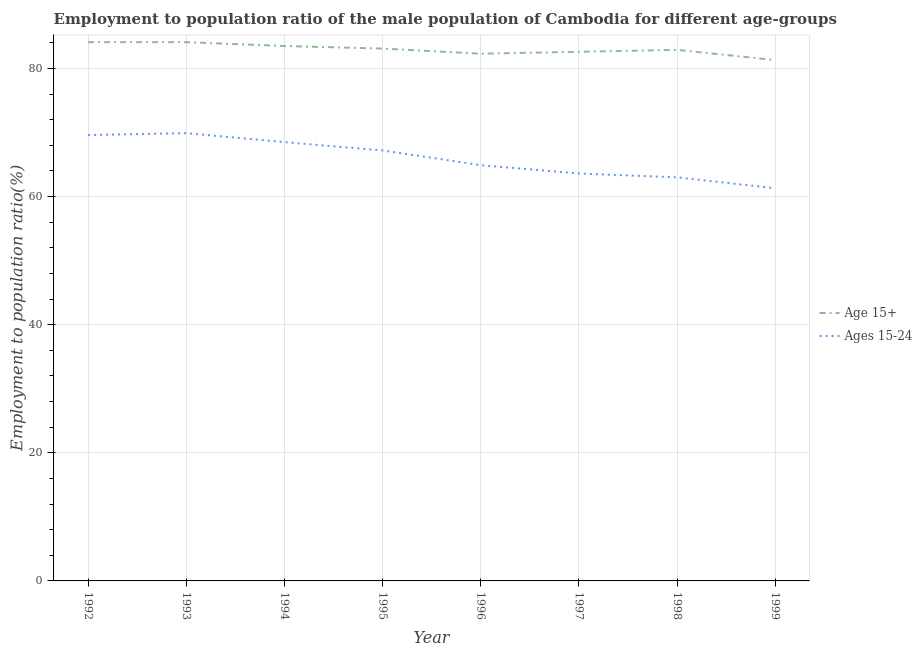Does the line corresponding to employment to population ratio(age 15-24) intersect with the line corresponding to employment to population ratio(age 15+)?
Make the answer very short. No. Is the number of lines equal to the number of legend labels?
Ensure brevity in your answer.  Yes. What is the employment to population ratio(age 15-24) in 1996?
Your response must be concise. 64.9. Across all years, what is the maximum employment to population ratio(age 15+)?
Your answer should be very brief. 84.1. Across all years, what is the minimum employment to population ratio(age 15-24)?
Make the answer very short. 61.3. In which year was the employment to population ratio(age 15+) maximum?
Your response must be concise. 1992. In which year was the employment to population ratio(age 15-24) minimum?
Provide a succinct answer. 1999. What is the total employment to population ratio(age 15-24) in the graph?
Provide a succinct answer. 528. What is the difference between the employment to population ratio(age 15+) in 1995 and that in 1997?
Offer a very short reply. 0.5. What is the difference between the employment to population ratio(age 15-24) in 1997 and the employment to population ratio(age 15+) in 1993?
Your response must be concise. -20.5. What is the average employment to population ratio(age 15+) per year?
Your answer should be very brief. 82.99. In the year 1993, what is the difference between the employment to population ratio(age 15+) and employment to population ratio(age 15-24)?
Your response must be concise. 14.2. In how many years, is the employment to population ratio(age 15+) greater than 24 %?
Provide a short and direct response. 8. What is the ratio of the employment to population ratio(age 15+) in 1998 to that in 1999?
Your response must be concise. 1.02. Is the employment to population ratio(age 15+) in 1995 less than that in 1998?
Provide a succinct answer. No. Is the difference between the employment to population ratio(age 15-24) in 1997 and 1999 greater than the difference between the employment to population ratio(age 15+) in 1997 and 1999?
Give a very brief answer. Yes. What is the difference between the highest and the second highest employment to population ratio(age 15+)?
Give a very brief answer. 0. What is the difference between the highest and the lowest employment to population ratio(age 15+)?
Ensure brevity in your answer.  2.8. In how many years, is the employment to population ratio(age 15-24) greater than the average employment to population ratio(age 15-24) taken over all years?
Make the answer very short. 4. Is the employment to population ratio(age 15-24) strictly greater than the employment to population ratio(age 15+) over the years?
Give a very brief answer. No. Is the employment to population ratio(age 15+) strictly less than the employment to population ratio(age 15-24) over the years?
Keep it short and to the point. No. How many lines are there?
Your answer should be compact. 2. Does the graph contain any zero values?
Provide a short and direct response. No. Does the graph contain grids?
Ensure brevity in your answer.  Yes. Where does the legend appear in the graph?
Your answer should be very brief. Center right. What is the title of the graph?
Provide a short and direct response. Employment to population ratio of the male population of Cambodia for different age-groups. Does "Import" appear as one of the legend labels in the graph?
Offer a very short reply. No. What is the Employment to population ratio(%) of Age 15+ in 1992?
Keep it short and to the point. 84.1. What is the Employment to population ratio(%) in Ages 15-24 in 1992?
Ensure brevity in your answer.  69.6. What is the Employment to population ratio(%) in Age 15+ in 1993?
Give a very brief answer. 84.1. What is the Employment to population ratio(%) in Ages 15-24 in 1993?
Offer a terse response. 69.9. What is the Employment to population ratio(%) of Age 15+ in 1994?
Make the answer very short. 83.5. What is the Employment to population ratio(%) of Ages 15-24 in 1994?
Give a very brief answer. 68.5. What is the Employment to population ratio(%) of Age 15+ in 1995?
Provide a succinct answer. 83.1. What is the Employment to population ratio(%) in Ages 15-24 in 1995?
Keep it short and to the point. 67.2. What is the Employment to population ratio(%) of Age 15+ in 1996?
Ensure brevity in your answer.  82.3. What is the Employment to population ratio(%) of Ages 15-24 in 1996?
Give a very brief answer. 64.9. What is the Employment to population ratio(%) in Age 15+ in 1997?
Your answer should be very brief. 82.6. What is the Employment to population ratio(%) in Ages 15-24 in 1997?
Provide a succinct answer. 63.6. What is the Employment to population ratio(%) in Age 15+ in 1998?
Make the answer very short. 82.9. What is the Employment to population ratio(%) of Age 15+ in 1999?
Provide a short and direct response. 81.3. What is the Employment to population ratio(%) in Ages 15-24 in 1999?
Keep it short and to the point. 61.3. Across all years, what is the maximum Employment to population ratio(%) of Age 15+?
Provide a succinct answer. 84.1. Across all years, what is the maximum Employment to population ratio(%) of Ages 15-24?
Your answer should be very brief. 69.9. Across all years, what is the minimum Employment to population ratio(%) of Age 15+?
Give a very brief answer. 81.3. Across all years, what is the minimum Employment to population ratio(%) in Ages 15-24?
Provide a succinct answer. 61.3. What is the total Employment to population ratio(%) of Age 15+ in the graph?
Offer a terse response. 663.9. What is the total Employment to population ratio(%) in Ages 15-24 in the graph?
Offer a very short reply. 528. What is the difference between the Employment to population ratio(%) in Ages 15-24 in 1992 and that in 1993?
Your answer should be very brief. -0.3. What is the difference between the Employment to population ratio(%) in Age 15+ in 1992 and that in 1994?
Offer a terse response. 0.6. What is the difference between the Employment to population ratio(%) in Ages 15-24 in 1992 and that in 1994?
Your answer should be compact. 1.1. What is the difference between the Employment to population ratio(%) of Age 15+ in 1992 and that in 1995?
Your answer should be compact. 1. What is the difference between the Employment to population ratio(%) in Ages 15-24 in 1992 and that in 1996?
Your answer should be very brief. 4.7. What is the difference between the Employment to population ratio(%) in Age 15+ in 1992 and that in 1997?
Your response must be concise. 1.5. What is the difference between the Employment to population ratio(%) of Ages 15-24 in 1992 and that in 1997?
Keep it short and to the point. 6. What is the difference between the Employment to population ratio(%) of Ages 15-24 in 1992 and that in 1999?
Offer a very short reply. 8.3. What is the difference between the Employment to population ratio(%) in Ages 15-24 in 1993 and that in 1994?
Your response must be concise. 1.4. What is the difference between the Employment to population ratio(%) in Age 15+ in 1993 and that in 1995?
Provide a short and direct response. 1. What is the difference between the Employment to population ratio(%) in Age 15+ in 1993 and that in 1996?
Make the answer very short. 1.8. What is the difference between the Employment to population ratio(%) in Age 15+ in 1993 and that in 1997?
Give a very brief answer. 1.5. What is the difference between the Employment to population ratio(%) of Age 15+ in 1993 and that in 1998?
Offer a very short reply. 1.2. What is the difference between the Employment to population ratio(%) of Ages 15-24 in 1993 and that in 1999?
Make the answer very short. 8.6. What is the difference between the Employment to population ratio(%) of Ages 15-24 in 1994 and that in 1995?
Provide a short and direct response. 1.3. What is the difference between the Employment to population ratio(%) in Age 15+ in 1994 and that in 1996?
Provide a succinct answer. 1.2. What is the difference between the Employment to population ratio(%) in Ages 15-24 in 1994 and that in 1996?
Give a very brief answer. 3.6. What is the difference between the Employment to population ratio(%) in Ages 15-24 in 1994 and that in 1998?
Your answer should be very brief. 5.5. What is the difference between the Employment to population ratio(%) in Age 15+ in 1994 and that in 1999?
Ensure brevity in your answer.  2.2. What is the difference between the Employment to population ratio(%) in Age 15+ in 1995 and that in 1996?
Your answer should be compact. 0.8. What is the difference between the Employment to population ratio(%) in Ages 15-24 in 1995 and that in 1996?
Ensure brevity in your answer.  2.3. What is the difference between the Employment to population ratio(%) of Age 15+ in 1995 and that in 1998?
Make the answer very short. 0.2. What is the difference between the Employment to population ratio(%) in Age 15+ in 1995 and that in 1999?
Make the answer very short. 1.8. What is the difference between the Employment to population ratio(%) of Age 15+ in 1996 and that in 1998?
Your answer should be very brief. -0.6. What is the difference between the Employment to population ratio(%) of Ages 15-24 in 1996 and that in 1999?
Provide a succinct answer. 3.6. What is the difference between the Employment to population ratio(%) of Age 15+ in 1997 and that in 1999?
Offer a very short reply. 1.3. What is the difference between the Employment to population ratio(%) of Ages 15-24 in 1997 and that in 1999?
Keep it short and to the point. 2.3. What is the difference between the Employment to population ratio(%) of Ages 15-24 in 1998 and that in 1999?
Give a very brief answer. 1.7. What is the difference between the Employment to population ratio(%) of Age 15+ in 1992 and the Employment to population ratio(%) of Ages 15-24 in 1998?
Give a very brief answer. 21.1. What is the difference between the Employment to population ratio(%) in Age 15+ in 1992 and the Employment to population ratio(%) in Ages 15-24 in 1999?
Give a very brief answer. 22.8. What is the difference between the Employment to population ratio(%) of Age 15+ in 1993 and the Employment to population ratio(%) of Ages 15-24 in 1996?
Your response must be concise. 19.2. What is the difference between the Employment to population ratio(%) in Age 15+ in 1993 and the Employment to population ratio(%) in Ages 15-24 in 1997?
Provide a short and direct response. 20.5. What is the difference between the Employment to population ratio(%) in Age 15+ in 1993 and the Employment to population ratio(%) in Ages 15-24 in 1998?
Offer a terse response. 21.1. What is the difference between the Employment to population ratio(%) in Age 15+ in 1993 and the Employment to population ratio(%) in Ages 15-24 in 1999?
Your answer should be compact. 22.8. What is the difference between the Employment to population ratio(%) of Age 15+ in 1994 and the Employment to population ratio(%) of Ages 15-24 in 1999?
Offer a very short reply. 22.2. What is the difference between the Employment to population ratio(%) in Age 15+ in 1995 and the Employment to population ratio(%) in Ages 15-24 in 1998?
Give a very brief answer. 20.1. What is the difference between the Employment to population ratio(%) of Age 15+ in 1995 and the Employment to population ratio(%) of Ages 15-24 in 1999?
Your response must be concise. 21.8. What is the difference between the Employment to population ratio(%) in Age 15+ in 1996 and the Employment to population ratio(%) in Ages 15-24 in 1997?
Make the answer very short. 18.7. What is the difference between the Employment to population ratio(%) of Age 15+ in 1996 and the Employment to population ratio(%) of Ages 15-24 in 1998?
Offer a terse response. 19.3. What is the difference between the Employment to population ratio(%) of Age 15+ in 1997 and the Employment to population ratio(%) of Ages 15-24 in 1998?
Offer a terse response. 19.6. What is the difference between the Employment to population ratio(%) of Age 15+ in 1997 and the Employment to population ratio(%) of Ages 15-24 in 1999?
Your response must be concise. 21.3. What is the difference between the Employment to population ratio(%) of Age 15+ in 1998 and the Employment to population ratio(%) of Ages 15-24 in 1999?
Provide a succinct answer. 21.6. What is the average Employment to population ratio(%) in Age 15+ per year?
Offer a terse response. 82.99. What is the average Employment to population ratio(%) in Ages 15-24 per year?
Keep it short and to the point. 66. In the year 1995, what is the difference between the Employment to population ratio(%) in Age 15+ and Employment to population ratio(%) in Ages 15-24?
Offer a terse response. 15.9. In the year 1998, what is the difference between the Employment to population ratio(%) of Age 15+ and Employment to population ratio(%) of Ages 15-24?
Make the answer very short. 19.9. What is the ratio of the Employment to population ratio(%) in Age 15+ in 1992 to that in 1994?
Your answer should be very brief. 1.01. What is the ratio of the Employment to population ratio(%) in Ages 15-24 in 1992 to that in 1994?
Your response must be concise. 1.02. What is the ratio of the Employment to population ratio(%) of Age 15+ in 1992 to that in 1995?
Provide a short and direct response. 1.01. What is the ratio of the Employment to population ratio(%) of Ages 15-24 in 1992 to that in 1995?
Your response must be concise. 1.04. What is the ratio of the Employment to population ratio(%) of Age 15+ in 1992 to that in 1996?
Offer a very short reply. 1.02. What is the ratio of the Employment to population ratio(%) in Ages 15-24 in 1992 to that in 1996?
Keep it short and to the point. 1.07. What is the ratio of the Employment to population ratio(%) of Age 15+ in 1992 to that in 1997?
Your answer should be very brief. 1.02. What is the ratio of the Employment to population ratio(%) of Ages 15-24 in 1992 to that in 1997?
Give a very brief answer. 1.09. What is the ratio of the Employment to population ratio(%) of Age 15+ in 1992 to that in 1998?
Offer a terse response. 1.01. What is the ratio of the Employment to population ratio(%) in Ages 15-24 in 1992 to that in 1998?
Offer a very short reply. 1.1. What is the ratio of the Employment to population ratio(%) of Age 15+ in 1992 to that in 1999?
Ensure brevity in your answer.  1.03. What is the ratio of the Employment to population ratio(%) in Ages 15-24 in 1992 to that in 1999?
Provide a short and direct response. 1.14. What is the ratio of the Employment to population ratio(%) in Ages 15-24 in 1993 to that in 1994?
Give a very brief answer. 1.02. What is the ratio of the Employment to population ratio(%) of Ages 15-24 in 1993 to that in 1995?
Ensure brevity in your answer.  1.04. What is the ratio of the Employment to population ratio(%) of Age 15+ in 1993 to that in 1996?
Provide a short and direct response. 1.02. What is the ratio of the Employment to population ratio(%) of Ages 15-24 in 1993 to that in 1996?
Keep it short and to the point. 1.08. What is the ratio of the Employment to population ratio(%) in Age 15+ in 1993 to that in 1997?
Offer a terse response. 1.02. What is the ratio of the Employment to population ratio(%) of Ages 15-24 in 1993 to that in 1997?
Give a very brief answer. 1.1. What is the ratio of the Employment to population ratio(%) in Age 15+ in 1993 to that in 1998?
Ensure brevity in your answer.  1.01. What is the ratio of the Employment to population ratio(%) of Ages 15-24 in 1993 to that in 1998?
Give a very brief answer. 1.11. What is the ratio of the Employment to population ratio(%) in Age 15+ in 1993 to that in 1999?
Give a very brief answer. 1.03. What is the ratio of the Employment to population ratio(%) in Ages 15-24 in 1993 to that in 1999?
Keep it short and to the point. 1.14. What is the ratio of the Employment to population ratio(%) in Ages 15-24 in 1994 to that in 1995?
Your answer should be very brief. 1.02. What is the ratio of the Employment to population ratio(%) of Age 15+ in 1994 to that in 1996?
Make the answer very short. 1.01. What is the ratio of the Employment to population ratio(%) of Ages 15-24 in 1994 to that in 1996?
Your answer should be compact. 1.06. What is the ratio of the Employment to population ratio(%) in Age 15+ in 1994 to that in 1997?
Provide a short and direct response. 1.01. What is the ratio of the Employment to population ratio(%) in Ages 15-24 in 1994 to that in 1997?
Give a very brief answer. 1.08. What is the ratio of the Employment to population ratio(%) of Ages 15-24 in 1994 to that in 1998?
Keep it short and to the point. 1.09. What is the ratio of the Employment to population ratio(%) of Age 15+ in 1994 to that in 1999?
Your answer should be very brief. 1.03. What is the ratio of the Employment to population ratio(%) in Ages 15-24 in 1994 to that in 1999?
Provide a succinct answer. 1.12. What is the ratio of the Employment to population ratio(%) in Age 15+ in 1995 to that in 1996?
Ensure brevity in your answer.  1.01. What is the ratio of the Employment to population ratio(%) in Ages 15-24 in 1995 to that in 1996?
Provide a short and direct response. 1.04. What is the ratio of the Employment to population ratio(%) of Ages 15-24 in 1995 to that in 1997?
Your answer should be compact. 1.06. What is the ratio of the Employment to population ratio(%) of Ages 15-24 in 1995 to that in 1998?
Provide a short and direct response. 1.07. What is the ratio of the Employment to population ratio(%) of Age 15+ in 1995 to that in 1999?
Provide a short and direct response. 1.02. What is the ratio of the Employment to population ratio(%) in Ages 15-24 in 1995 to that in 1999?
Make the answer very short. 1.1. What is the ratio of the Employment to population ratio(%) in Ages 15-24 in 1996 to that in 1997?
Your response must be concise. 1.02. What is the ratio of the Employment to population ratio(%) of Age 15+ in 1996 to that in 1998?
Ensure brevity in your answer.  0.99. What is the ratio of the Employment to population ratio(%) in Ages 15-24 in 1996 to that in 1998?
Keep it short and to the point. 1.03. What is the ratio of the Employment to population ratio(%) in Age 15+ in 1996 to that in 1999?
Make the answer very short. 1.01. What is the ratio of the Employment to population ratio(%) in Ages 15-24 in 1996 to that in 1999?
Ensure brevity in your answer.  1.06. What is the ratio of the Employment to population ratio(%) of Ages 15-24 in 1997 to that in 1998?
Ensure brevity in your answer.  1.01. What is the ratio of the Employment to population ratio(%) in Age 15+ in 1997 to that in 1999?
Keep it short and to the point. 1.02. What is the ratio of the Employment to population ratio(%) in Ages 15-24 in 1997 to that in 1999?
Your response must be concise. 1.04. What is the ratio of the Employment to population ratio(%) in Age 15+ in 1998 to that in 1999?
Your answer should be compact. 1.02. What is the ratio of the Employment to population ratio(%) in Ages 15-24 in 1998 to that in 1999?
Make the answer very short. 1.03. What is the difference between the highest and the second highest Employment to population ratio(%) of Age 15+?
Make the answer very short. 0. What is the difference between the highest and the lowest Employment to population ratio(%) in Age 15+?
Make the answer very short. 2.8. 